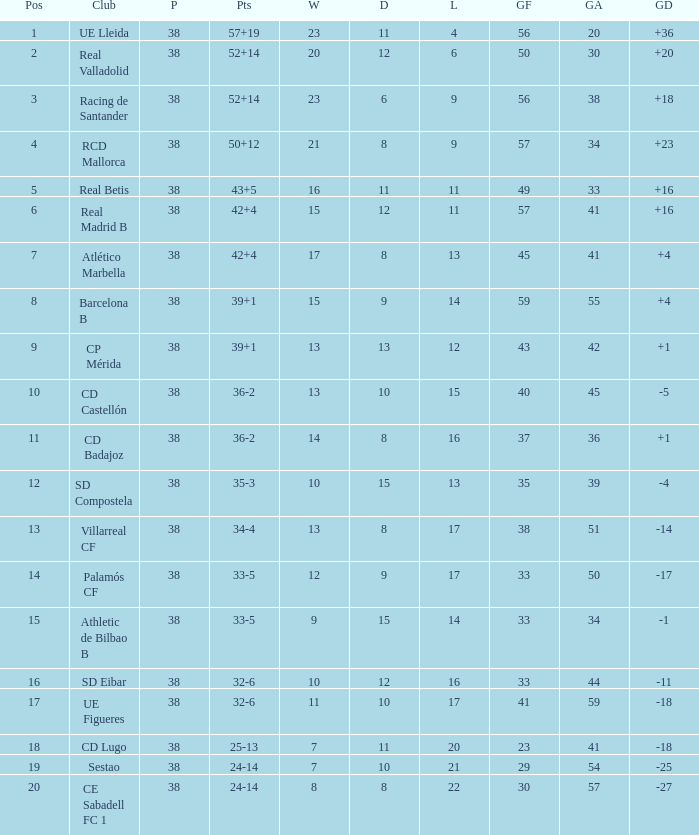What is the highest number of loss with a 7 position and more than 45 goals? None. Write the full table. {'header': ['Pos', 'Club', 'P', 'Pts', 'W', 'D', 'L', 'GF', 'GA', 'GD'], 'rows': [['1', 'UE Lleida', '38', '57+19', '23', '11', '4', '56', '20', '+36'], ['2', 'Real Valladolid', '38', '52+14', '20', '12', '6', '50', '30', '+20'], ['3', 'Racing de Santander', '38', '52+14', '23', '6', '9', '56', '38', '+18'], ['4', 'RCD Mallorca', '38', '50+12', '21', '8', '9', '57', '34', '+23'], ['5', 'Real Betis', '38', '43+5', '16', '11', '11', '49', '33', '+16'], ['6', 'Real Madrid B', '38', '42+4', '15', '12', '11', '57', '41', '+16'], ['7', 'Atlético Marbella', '38', '42+4', '17', '8', '13', '45', '41', '+4'], ['8', 'Barcelona B', '38', '39+1', '15', '9', '14', '59', '55', '+4'], ['9', 'CP Mérida', '38', '39+1', '13', '13', '12', '43', '42', '+1'], ['10', 'CD Castellón', '38', '36-2', '13', '10', '15', '40', '45', '-5'], ['11', 'CD Badajoz', '38', '36-2', '14', '8', '16', '37', '36', '+1'], ['12', 'SD Compostela', '38', '35-3', '10', '15', '13', '35', '39', '-4'], ['13', 'Villarreal CF', '38', '34-4', '13', '8', '17', '38', '51', '-14'], ['14', 'Palamós CF', '38', '33-5', '12', '9', '17', '33', '50', '-17'], ['15', 'Athletic de Bilbao B', '38', '33-5', '9', '15', '14', '33', '34', '-1'], ['16', 'SD Eibar', '38', '32-6', '10', '12', '16', '33', '44', '-11'], ['17', 'UE Figueres', '38', '32-6', '11', '10', '17', '41', '59', '-18'], ['18', 'CD Lugo', '38', '25-13', '7', '11', '20', '23', '41', '-18'], ['19', 'Sestao', '38', '24-14', '7', '10', '21', '29', '54', '-25'], ['20', 'CE Sabadell FC 1', '38', '24-14', '8', '8', '22', '30', '57', '-27']]} 